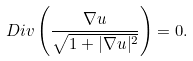<formula> <loc_0><loc_0><loc_500><loc_500>\ D i v \left ( \frac { \nabla u } { \sqrt { 1 + | \nabla u | ^ { 2 } } } \right ) = 0 .</formula> 